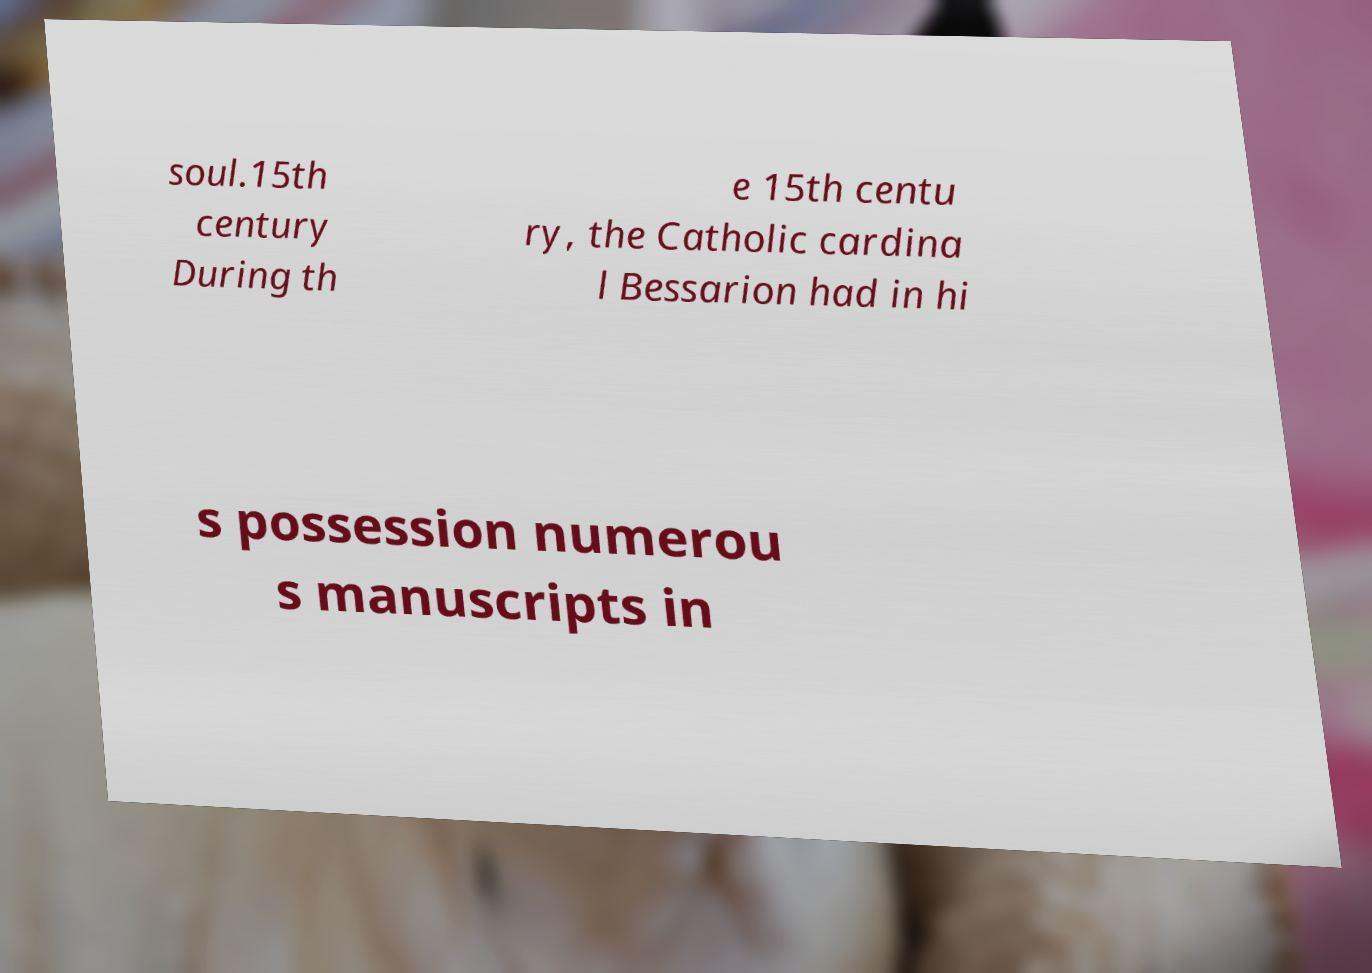Could you extract and type out the text from this image? soul.15th century During th e 15th centu ry, the Catholic cardina l Bessarion had in hi s possession numerou s manuscripts in 